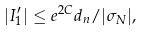Convert formula to latex. <formula><loc_0><loc_0><loc_500><loc_500>| I _ { 1 } ^ { \prime } | \leq e ^ { 2 C } d _ { n } / | \sigma _ { N } | ,</formula> 